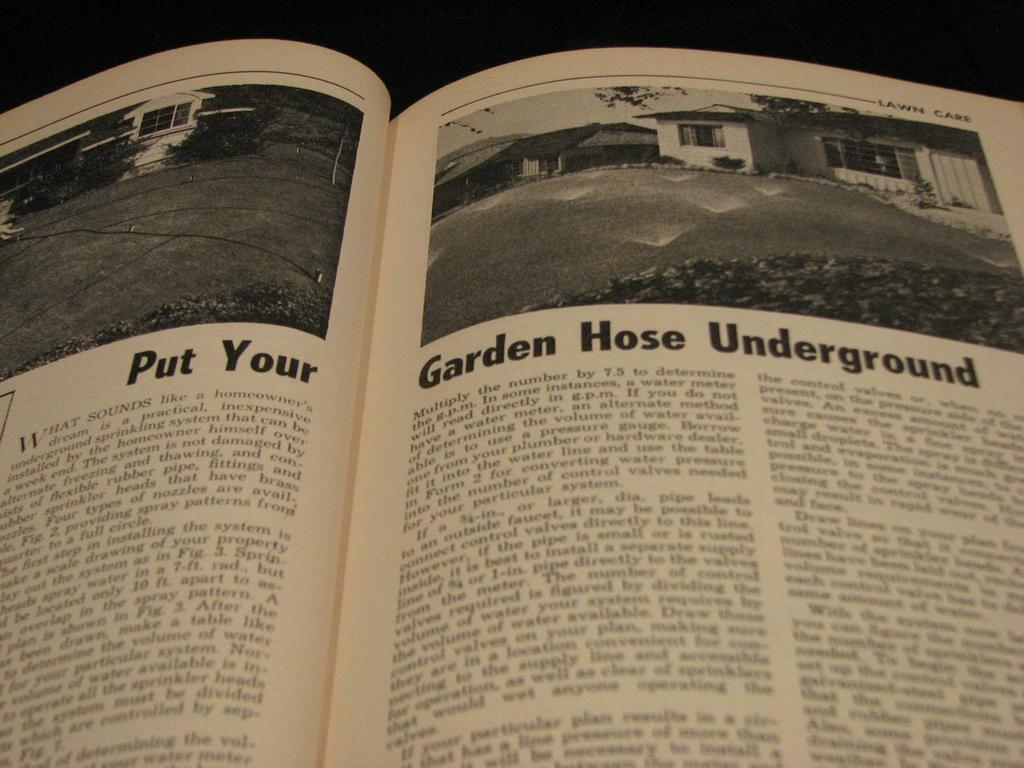<image>
Give a short and clear explanation of the subsequent image. An open book showing a section about lawn care under the header Put Your Garden Hose Underground. 